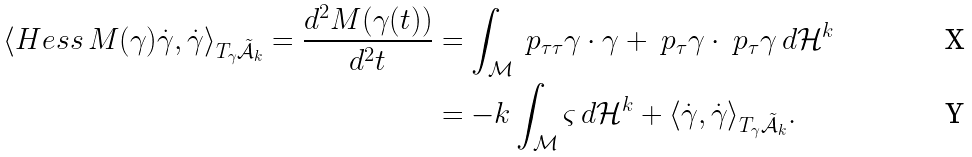<formula> <loc_0><loc_0><loc_500><loc_500>\langle H e s s \, M ( \gamma ) \dot { \gamma } , \dot { \gamma } \rangle _ { T _ { \gamma } \tilde { \mathcal { A } } _ { k } } = \frac { d ^ { 2 } M ( \gamma ( t ) ) } { d ^ { 2 } t } & = \int _ { \mathcal { M } } \ p _ { \tau \tau } \gamma \cdot \gamma + \ p _ { \tau } \gamma \cdot \ p _ { \tau } \gamma \, d \mathcal { H } ^ { k } \\ & = - k \int _ { \mathcal { M } } \varsigma \, d \mathcal { H } ^ { k } + \langle \dot { \gamma } , \dot { \gamma } \rangle _ { T _ { \gamma } \tilde { \mathcal { A } } _ { k } } .</formula> 